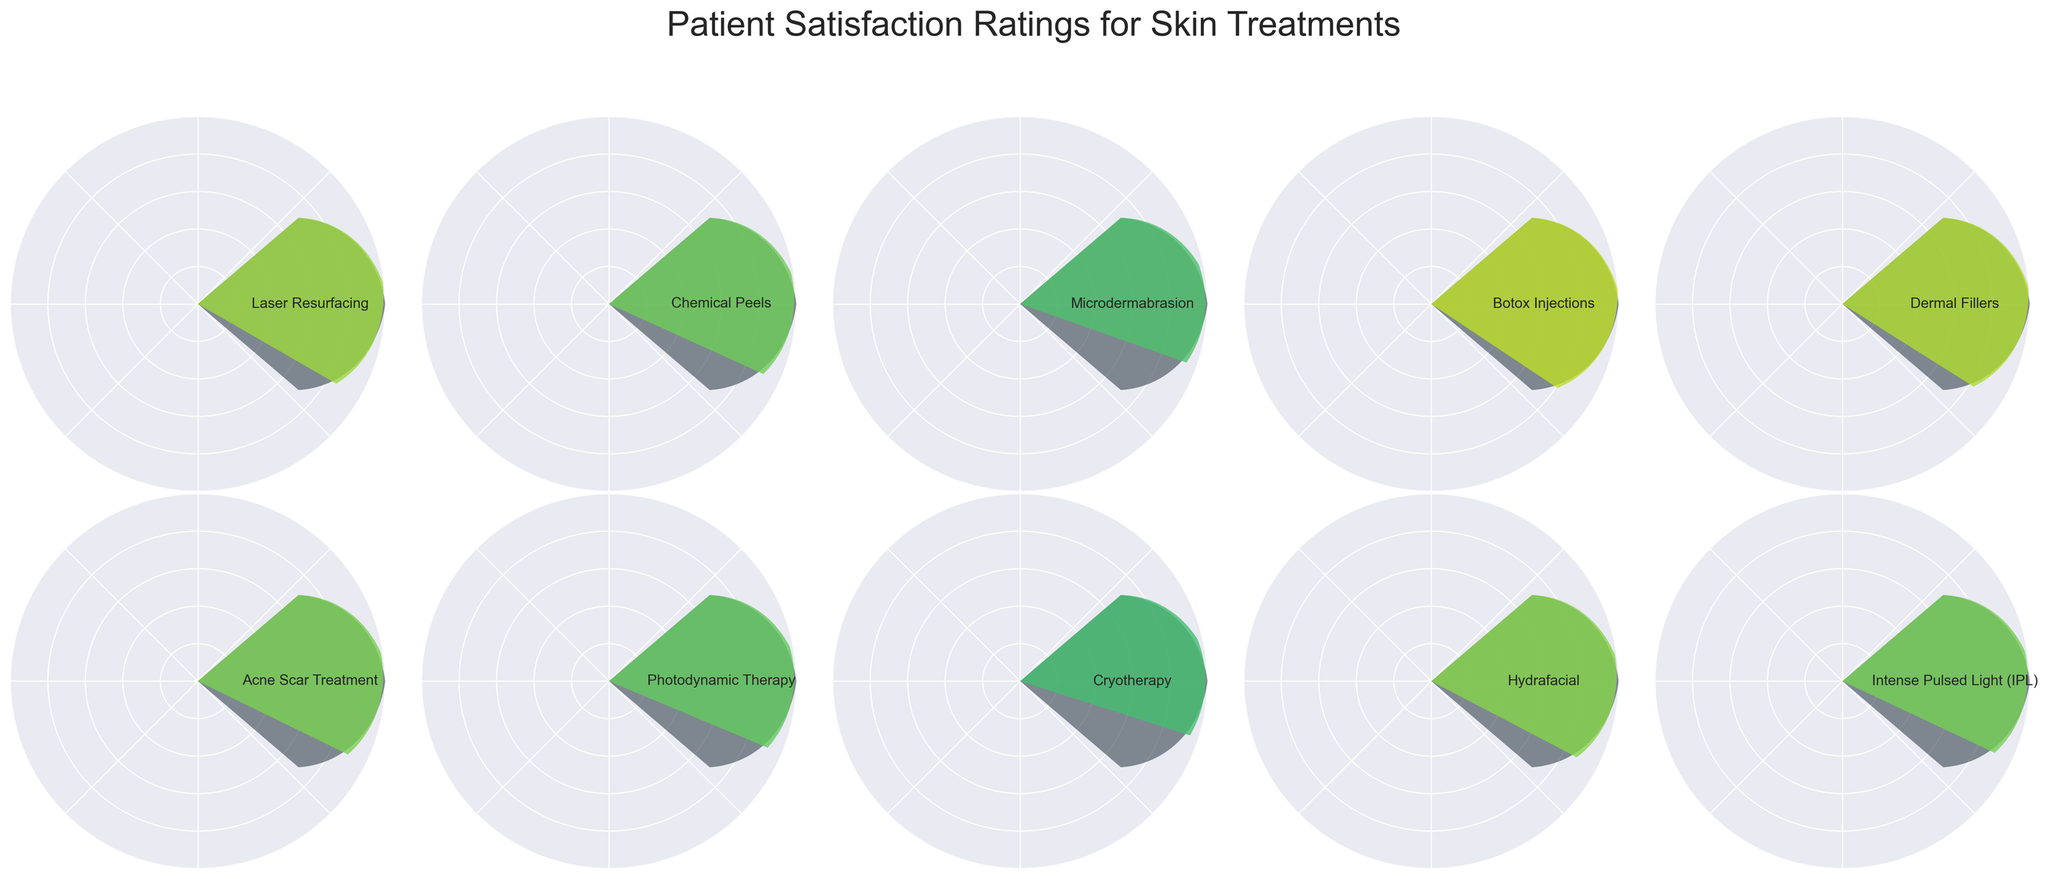What is the highest patient satisfaction rating among the treatments? The highest rating is found by simply identifying the largest number among the ratings on the gauge charts. The highest rating is 90% for Botox Injections.
Answer: 90% Which treatment has the lowest patient satisfaction rating? Identify the lowest number among the satisfaction ratings. The lowest rating is for Cryotherapy, which is 70%.
Answer: Cryotherapy What is the average satisfaction rating for all treatments? Add all the satisfaction ratings and divide by the number of treatments. The sum of the ratings is 800 and there are 10 treatments, so the average is 800/10 = 80%.
Answer: 80% What is the median satisfaction rating for the treatments? First, list the satisfaction ratings in ascending order: 70, 72, 76, 78, 79, 80, 82, 85, 88, 90. Since there is an even number of treatments, the median is the average of the 5th and 6th values: (79 + 80) / 2 = 79.5
Answer: 79.5 How many treatments have a satisfaction rating above 80%? Count the treatments with ratings greater than 80%. These treatments are Laser Resurfacing, Botox Injections, Dermal Fillers, Hydrafacial, and Acne Scar Treatment. There are 5 of them.
Answer: 5 Which treatment has the most similar satisfaction rating to Chemical Peels? Identify the rating for Chemical Peels (78%) and then find the closest value among other treatments. Intense Pulsed Light (79%) is the closest.
Answer: Intense Pulsed Light (IPL) What is the range of patient satisfaction ratings across all treatments? Subtract the lowest rating from the highest rating. The highest is 90% and the lowest is 70%, so the range is 90 - 70 = 20%.
Answer: 20% How does the satisfaction rating of Microdermabrasion compare to that of Cryotherapy? The rating for Microdermabrasion is 72% and for Cryotherapy is 70%. Microdermabrasion has a higher rating by 2%.
Answer: Microdermabrasion is higher by 2% Calculate the difference between the highest and the median satisfaction rating. The highest rating is 90%, and the median is 79.5%. The difference is 90 - 79.5 = 10.5%.
Answer: 10.5% 